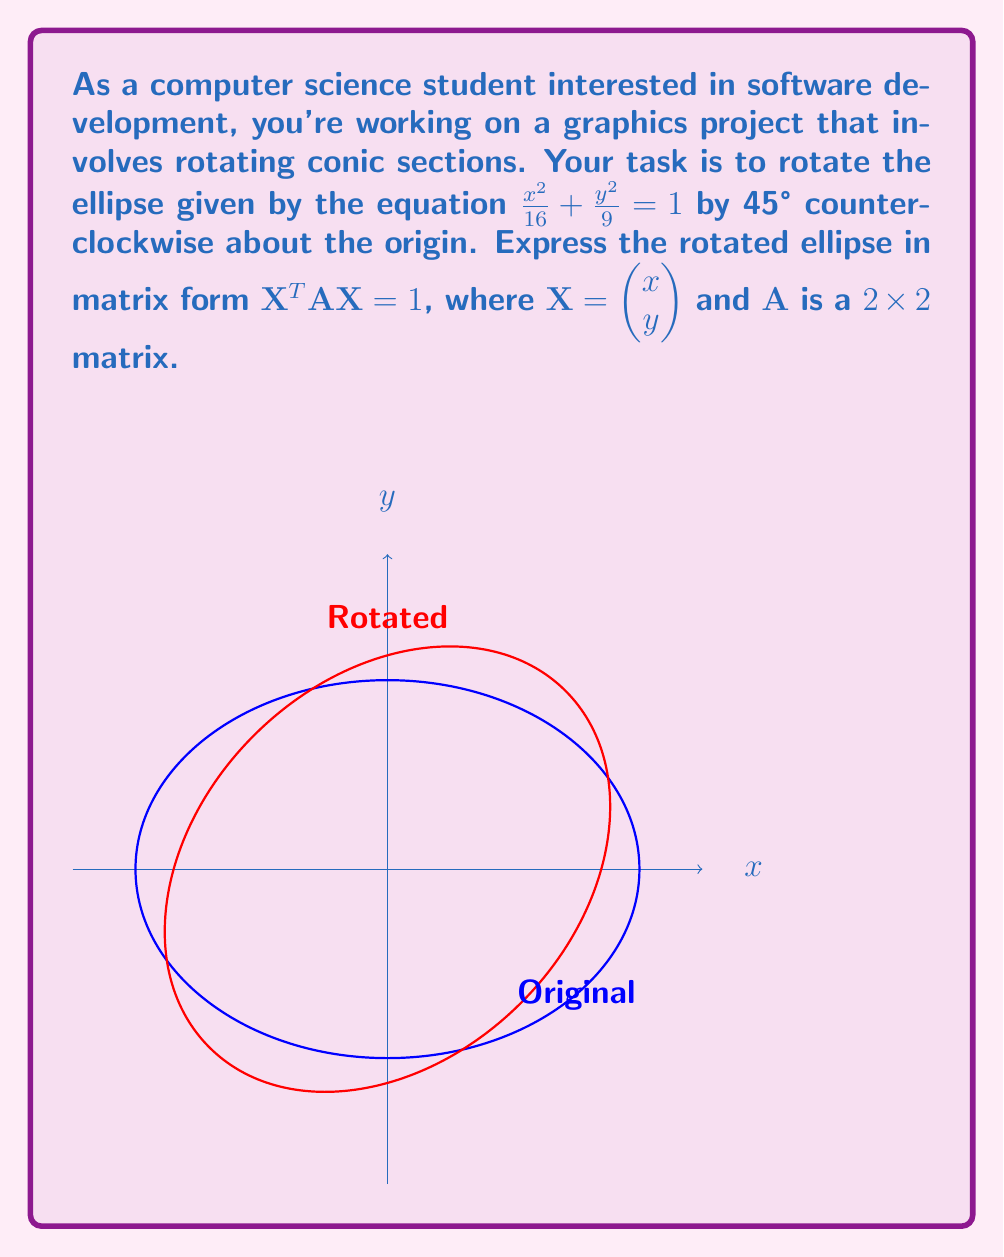Teach me how to tackle this problem. Let's approach this step-by-step:

1) First, we need to express the original ellipse in matrix form. The equation $\frac{x^2}{16} + \frac{y^2}{9} = 1$ can be written as:

   $$\begin{pmatrix} x & y \end{pmatrix} \begin{pmatrix} \frac{1}{16} & 0 \\ 0 & \frac{1}{9} \end{pmatrix} \begin{pmatrix} x \\ y \end{pmatrix} = 1$$

2) To rotate the ellipse, we need to use the rotation matrix for 45°:

   $$R = \begin{pmatrix} \cos 45° & -\sin 45° \\ \sin 45° & \cos 45° \end{pmatrix} = \frac{1}{\sqrt{2}} \begin{pmatrix} 1 & -1 \\ 1 & 1 \end{pmatrix}$$

3) The rotation is applied by transforming the coordinates: $\mathbf{X'} = R\mathbf{X}$, where $\mathbf{X'}$ represents the rotated coordinates.

4) Substituting this into the original equation:

   $$\mathbf{X'}^T\mathbf{A}\mathbf{X'} = (R\mathbf{X})^T\mathbf{A}(R\mathbf{X}) = \mathbf{X}^T R^T \mathbf{A} R \mathbf{X} = 1$$

5) Therefore, the matrix $\mathbf{A'}$ for the rotated ellipse is:

   $$\mathbf{A'} = R^T \mathbf{A} R$$

6) Let's compute this:

   $$\mathbf{A'} = \frac{1}{2} \begin{pmatrix} 1 & 1 \\ -1 & 1 \end{pmatrix} \begin{pmatrix} \frac{1}{16} & 0 \\ 0 & \frac{1}{9} \end{pmatrix} \begin{pmatrix} 1 & -1 \\ 1 & 1 \end{pmatrix}$$

7) Multiplying these matrices:

   $$\mathbf{A'} = \frac{1}{2} \begin{pmatrix} \frac{1}{16} + \frac{1}{9} & \frac{1}{16} - \frac{1}{9} \\ \frac{1}{16} - \frac{1}{9} & \frac{1}{16} + \frac{1}{9} \end{pmatrix} = \begin{pmatrix} \frac{25}{288} & \frac{-7}{288} \\ \frac{-7}{288} & \frac{25}{288} \end{pmatrix}$$

This matrix $\mathbf{A'}$ represents the rotated ellipse in the form $\mathbf{X}^T\mathbf{A'}\mathbf{X} = 1$.
Answer: $$\mathbf{A'} = \begin{pmatrix} \frac{25}{288} & \frac{-7}{288} \\ \frac{-7}{288} & \frac{25}{288} \end{pmatrix}$$ 